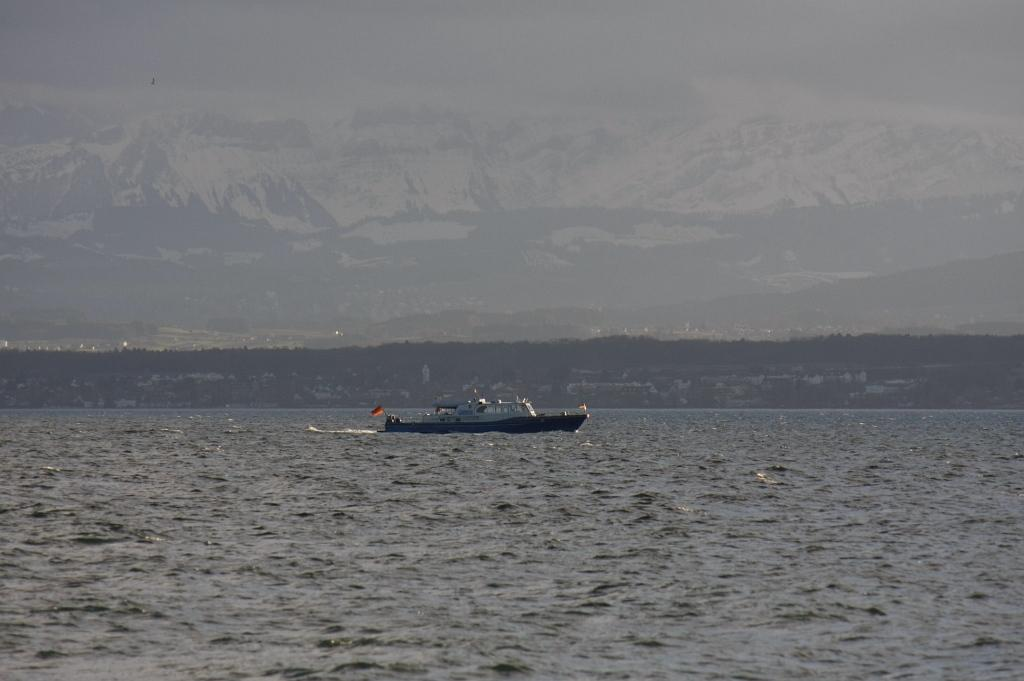What is the main subject of the image? The main subject of the image is a boat. Where is the boat located? The boat is on the water. What can be seen in the background of the image? There are trees, mountains, and some objects visible in the background of the image. What else is visible in the background of the image? The sky is visible in the background of the image. What type of pain is the boat experiencing in the image? There is no indication of pain in the image; the boat is simply on the water. Can you see a crook in the image? There is no crook present in the image. 